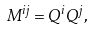Convert formula to latex. <formula><loc_0><loc_0><loc_500><loc_500>M ^ { i j } = Q ^ { i } Q ^ { j } ,</formula> 